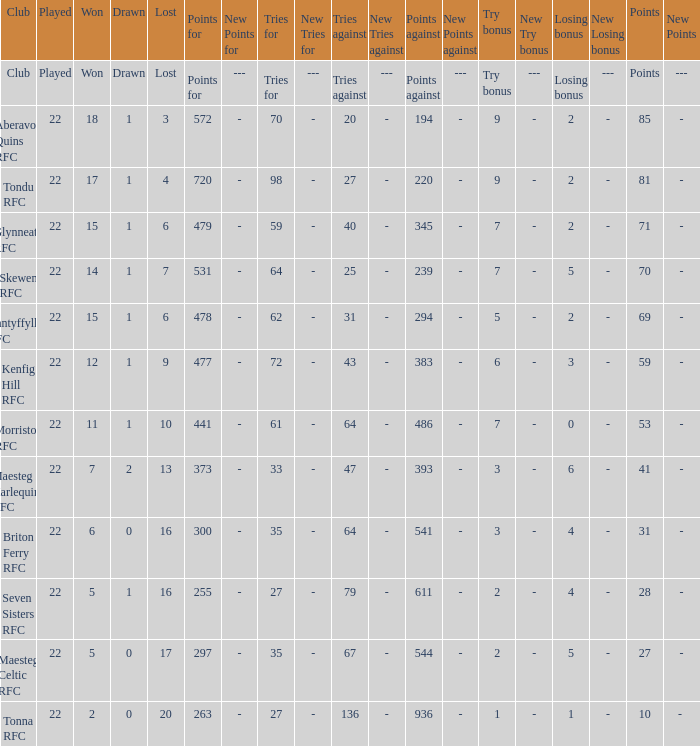Which club had 239 points scored against them? Skewen RFC. 